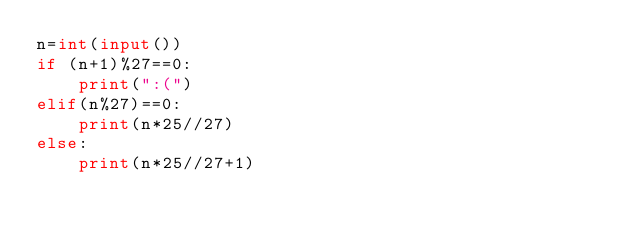<code> <loc_0><loc_0><loc_500><loc_500><_Python_>n=int(input())
if (n+1)%27==0:
    print(":(")
elif(n%27)==0:
    print(n*25//27)
else:
    print(n*25//27+1)</code> 